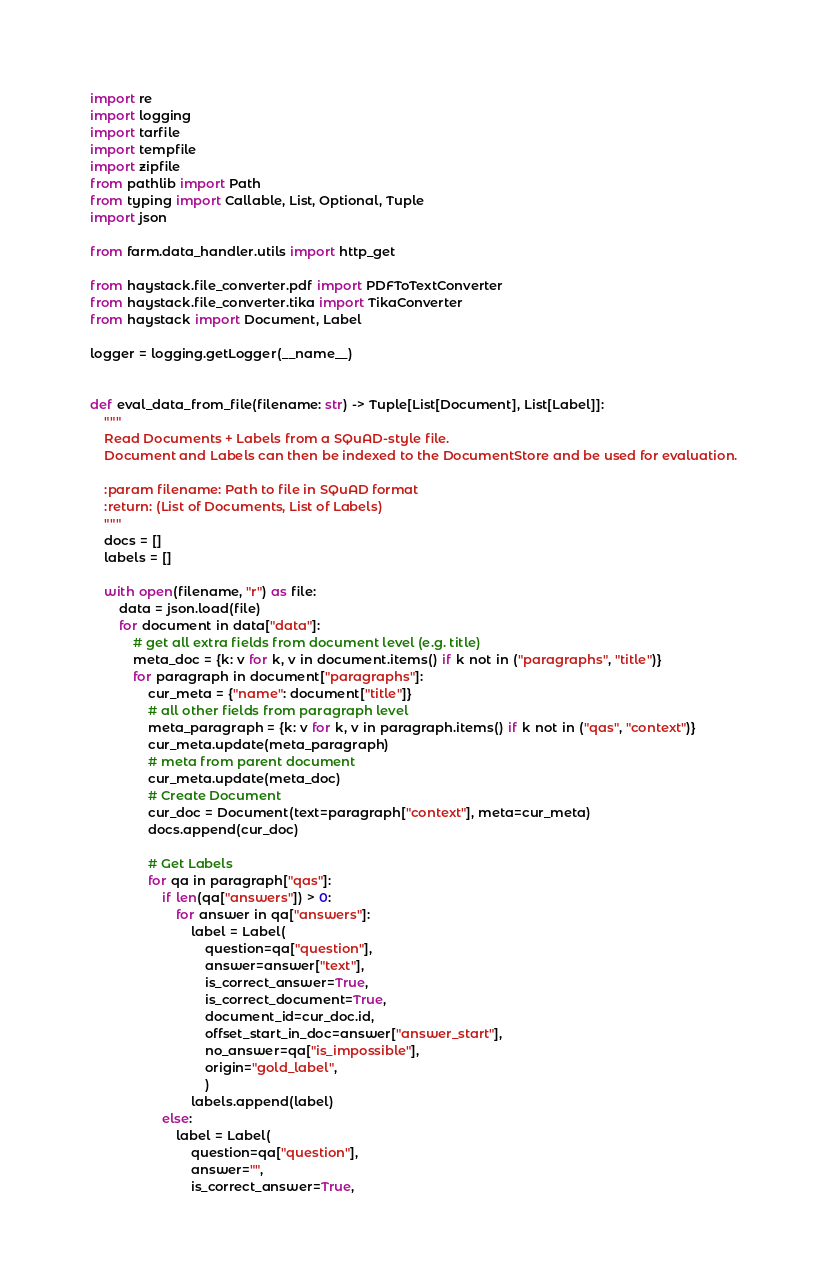<code> <loc_0><loc_0><loc_500><loc_500><_Python_>import re
import logging
import tarfile
import tempfile
import zipfile
from pathlib import Path
from typing import Callable, List, Optional, Tuple
import json

from farm.data_handler.utils import http_get

from haystack.file_converter.pdf import PDFToTextConverter
from haystack.file_converter.tika import TikaConverter
from haystack import Document, Label

logger = logging.getLogger(__name__)


def eval_data_from_file(filename: str) -> Tuple[List[Document], List[Label]]:
    """
    Read Documents + Labels from a SQuAD-style file.
    Document and Labels can then be indexed to the DocumentStore and be used for evaluation.

    :param filename: Path to file in SQuAD format
    :return: (List of Documents, List of Labels)
    """
    docs = []
    labels = []

    with open(filename, "r") as file:
        data = json.load(file)
        for document in data["data"]:
            # get all extra fields from document level (e.g. title)
            meta_doc = {k: v for k, v in document.items() if k not in ("paragraphs", "title")}
            for paragraph in document["paragraphs"]:
                cur_meta = {"name": document["title"]}
                # all other fields from paragraph level
                meta_paragraph = {k: v for k, v in paragraph.items() if k not in ("qas", "context")}
                cur_meta.update(meta_paragraph)
                # meta from parent document
                cur_meta.update(meta_doc)
                # Create Document
                cur_doc = Document(text=paragraph["context"], meta=cur_meta)
                docs.append(cur_doc)

                # Get Labels
                for qa in paragraph["qas"]:
                    if len(qa["answers"]) > 0:
                        for answer in qa["answers"]:
                            label = Label(
                                question=qa["question"],
                                answer=answer["text"],
                                is_correct_answer=True,
                                is_correct_document=True,
                                document_id=cur_doc.id,
                                offset_start_in_doc=answer["answer_start"],
                                no_answer=qa["is_impossible"],
                                origin="gold_label",
                                )
                            labels.append(label)
                    else:
                        label = Label(
                            question=qa["question"],
                            answer="",
                            is_correct_answer=True,</code> 